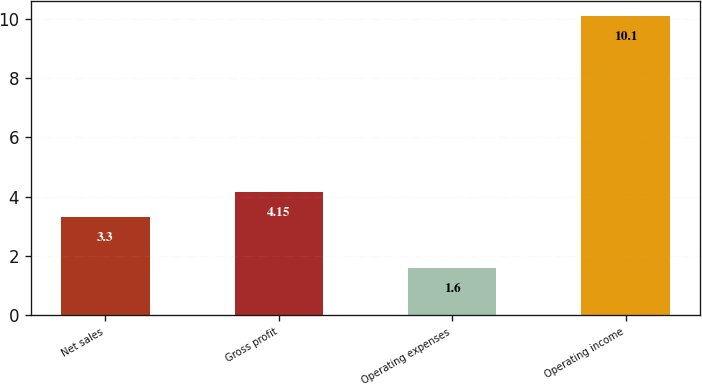Convert chart. <chart><loc_0><loc_0><loc_500><loc_500><bar_chart><fcel>Net sales<fcel>Gross profit<fcel>Operating expenses<fcel>Operating income<nl><fcel>3.3<fcel>4.15<fcel>1.6<fcel>10.1<nl></chart> 